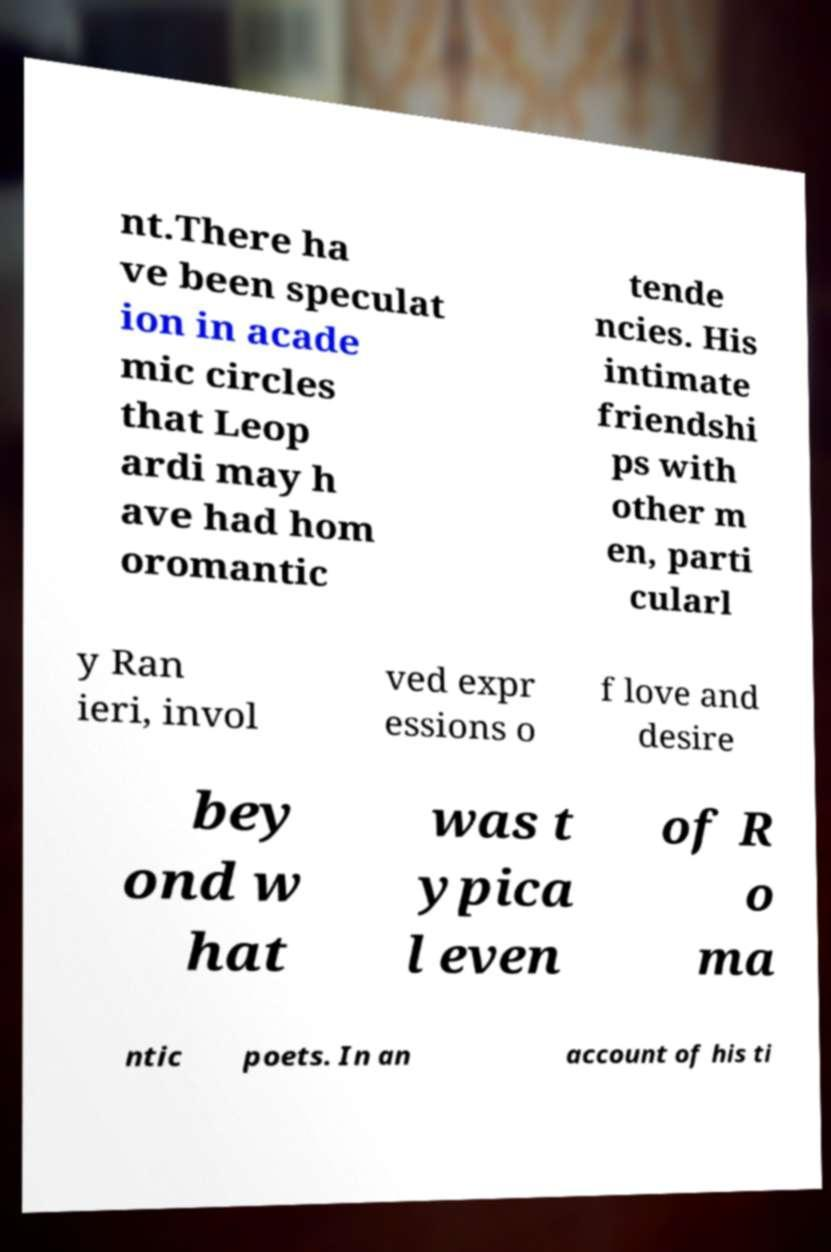Can you read and provide the text displayed in the image?This photo seems to have some interesting text. Can you extract and type it out for me? nt.There ha ve been speculat ion in acade mic circles that Leop ardi may h ave had hom oromantic tende ncies. His intimate friendshi ps with other m en, parti cularl y Ran ieri, invol ved expr essions o f love and desire bey ond w hat was t ypica l even of R o ma ntic poets. In an account of his ti 